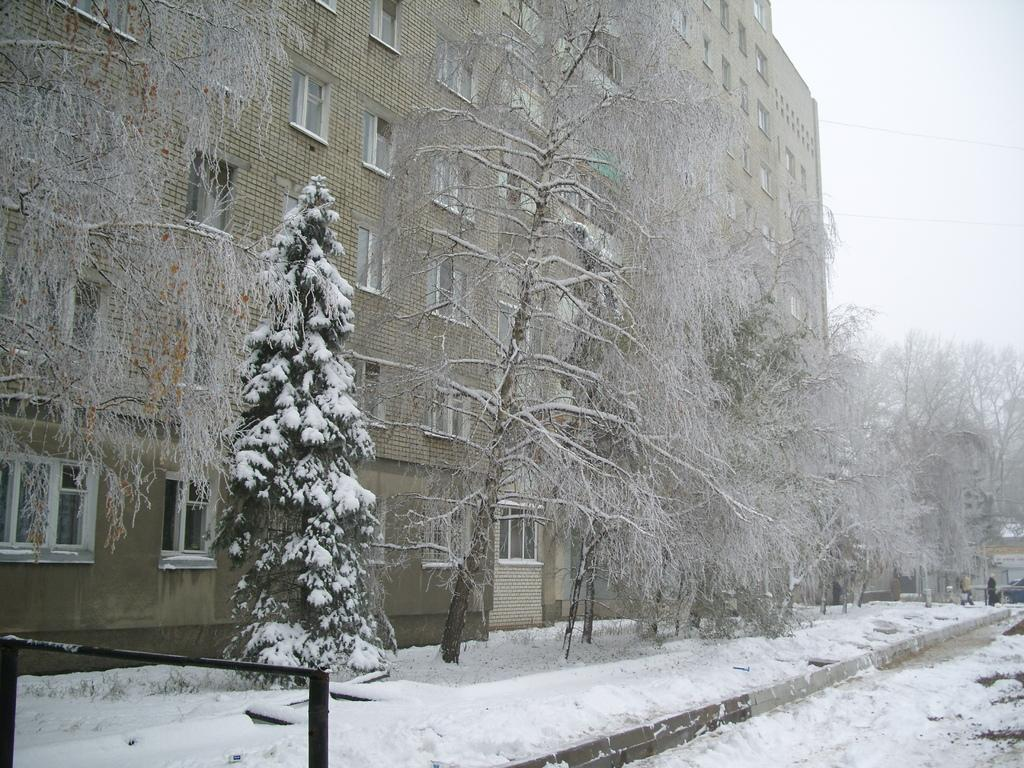What type of structure is present in the image? There is a building in the image. What feature can be seen on the building? The building has windows. What type of vegetation is visible in the image? There are trees visible in the image. What weather condition is depicted in the image? There is snow visible in the image. What else can be seen in the sky in the image? The sky is visible in the image. What type of owl can be seen perched on the business sign in the image? There is no owl or business sign present in the image. What type of pump is visible in the image? There is no pump visible in the image. 